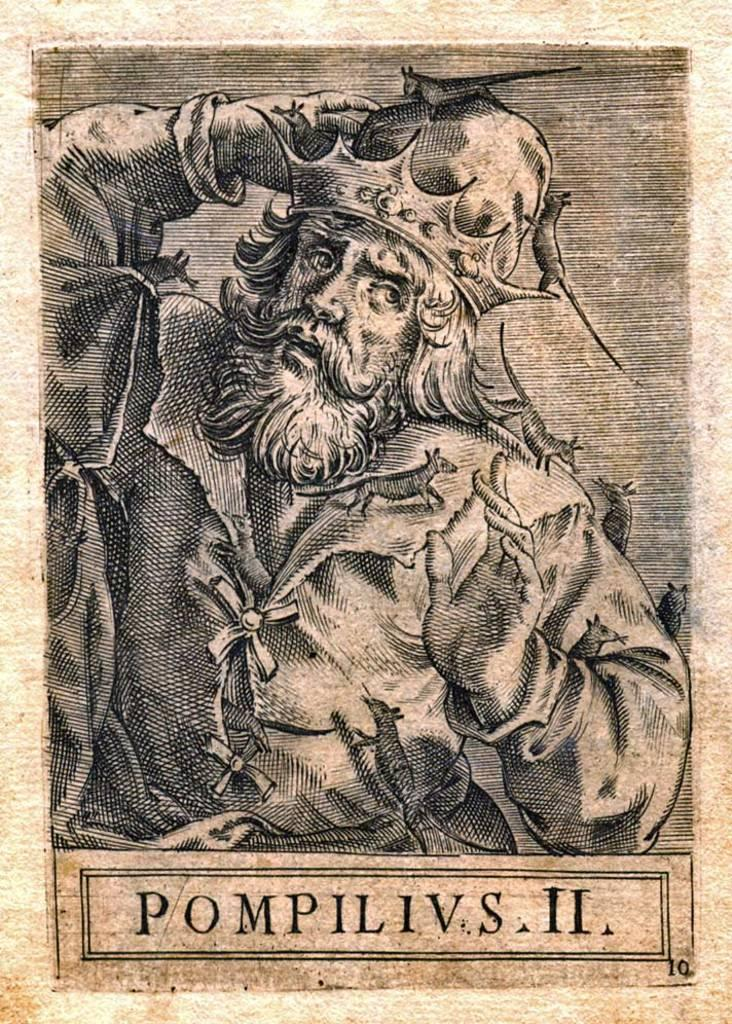<image>
Share a concise interpretation of the image provided. Poster showing a man with a beard titled "Pompilivs II". 